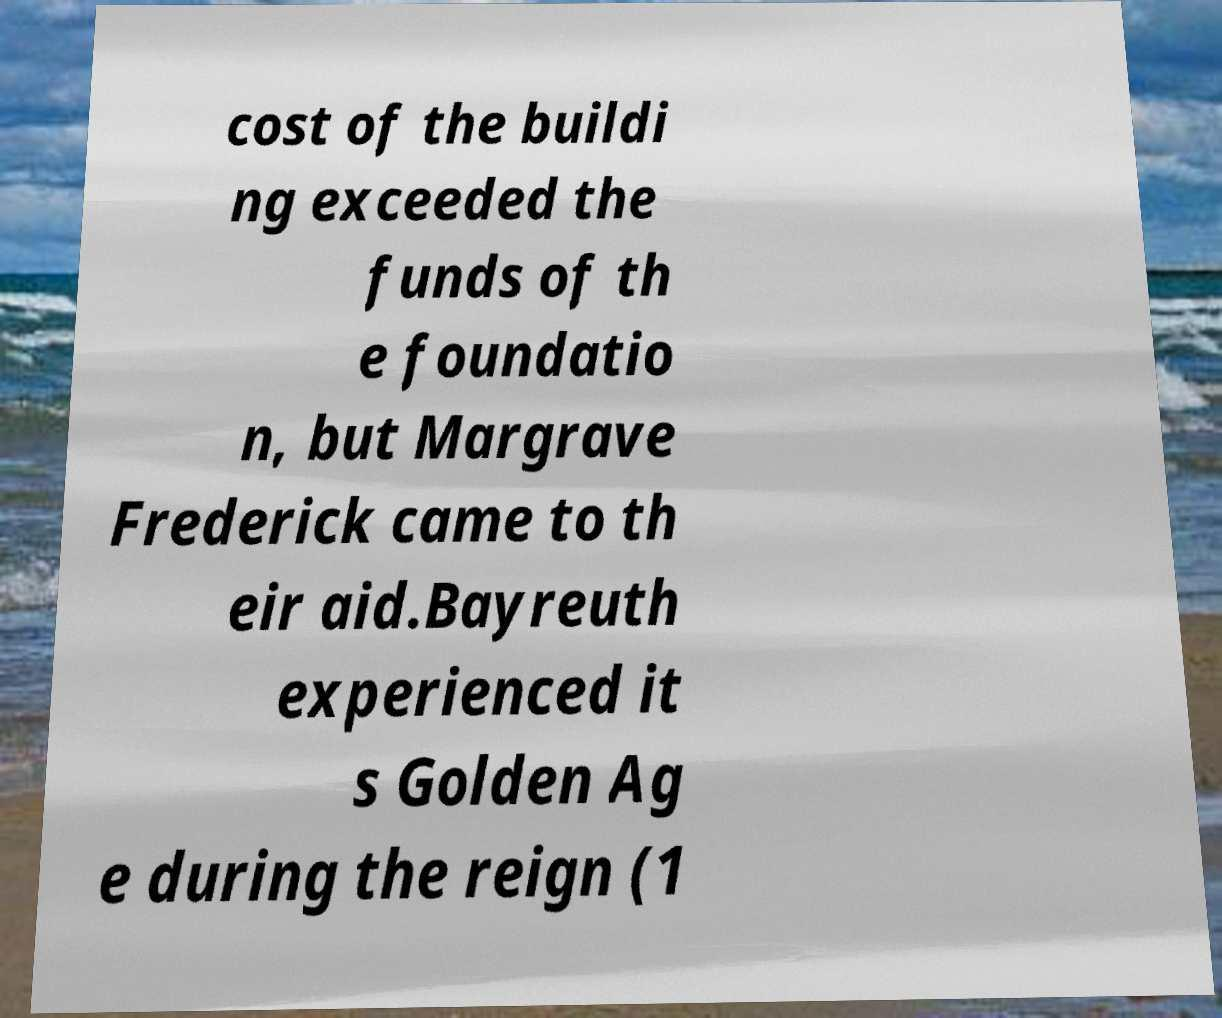Could you extract and type out the text from this image? cost of the buildi ng exceeded the funds of th e foundatio n, but Margrave Frederick came to th eir aid.Bayreuth experienced it s Golden Ag e during the reign (1 